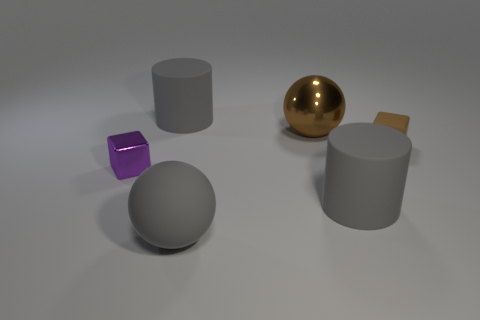Is there another thing that has the same shape as the small brown matte thing?
Offer a very short reply. Yes. What shape is the tiny shiny object?
Your response must be concise. Cube. How many objects are purple balls or rubber spheres?
Ensure brevity in your answer.  1. Do the metallic object that is in front of the brown matte cube and the metal object behind the purple object have the same size?
Make the answer very short. No. How many other things are made of the same material as the small purple thing?
Offer a very short reply. 1. Is the number of big gray cylinders left of the metallic ball greater than the number of big cylinders that are behind the small brown matte thing?
Offer a terse response. No. There is a tiny block right of the gray matte ball; what is its material?
Ensure brevity in your answer.  Rubber. Is the shape of the purple metal object the same as the brown matte thing?
Your response must be concise. Yes. Is there anything else that is the same color as the big metal sphere?
Keep it short and to the point. Yes. What color is the other tiny thing that is the same shape as the brown rubber thing?
Provide a succinct answer. Purple. 